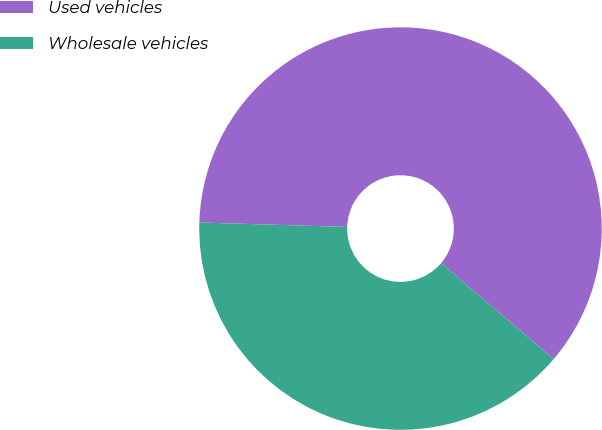<chart> <loc_0><loc_0><loc_500><loc_500><pie_chart><fcel>Used vehicles<fcel>Wholesale vehicles<nl><fcel>60.75%<fcel>39.25%<nl></chart> 